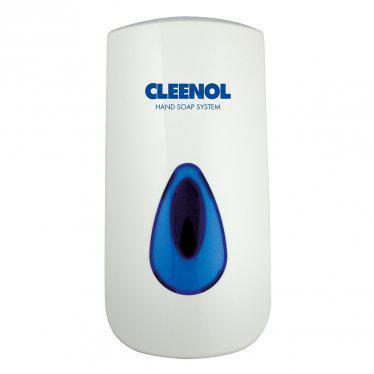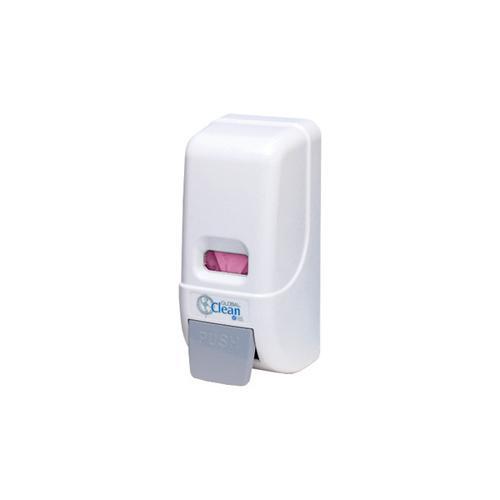The first image is the image on the left, the second image is the image on the right. Evaluate the accuracy of this statement regarding the images: "There are at least two dispensers in the image on the right.". Is it true? Answer yes or no. No. 